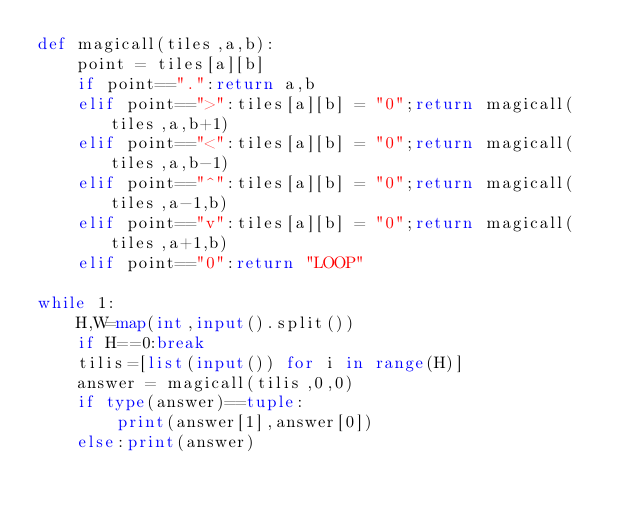Convert code to text. <code><loc_0><loc_0><loc_500><loc_500><_Python_>def magicall(tiles,a,b):
    point = tiles[a][b]
    if point==".":return a,b
    elif point==">":tiles[a][b] = "0";return magicall(tiles,a,b+1)
    elif point=="<":tiles[a][b] = "0";return magicall(tiles,a,b-1)
    elif point=="^":tiles[a][b] = "0";return magicall(tiles,a-1,b)
    elif point=="v":tiles[a][b] = "0";return magicall(tiles,a+1,b)
    elif point=="0":return "LOOP"

while 1:
    H,W=map(int,input().split())
    if H==0:break
    tilis=[list(input()) for i in range(H)]
    answer = magicall(tilis,0,0)
    if type(answer)==tuple:
        print(answer[1],answer[0])
    else:print(answer)
</code> 